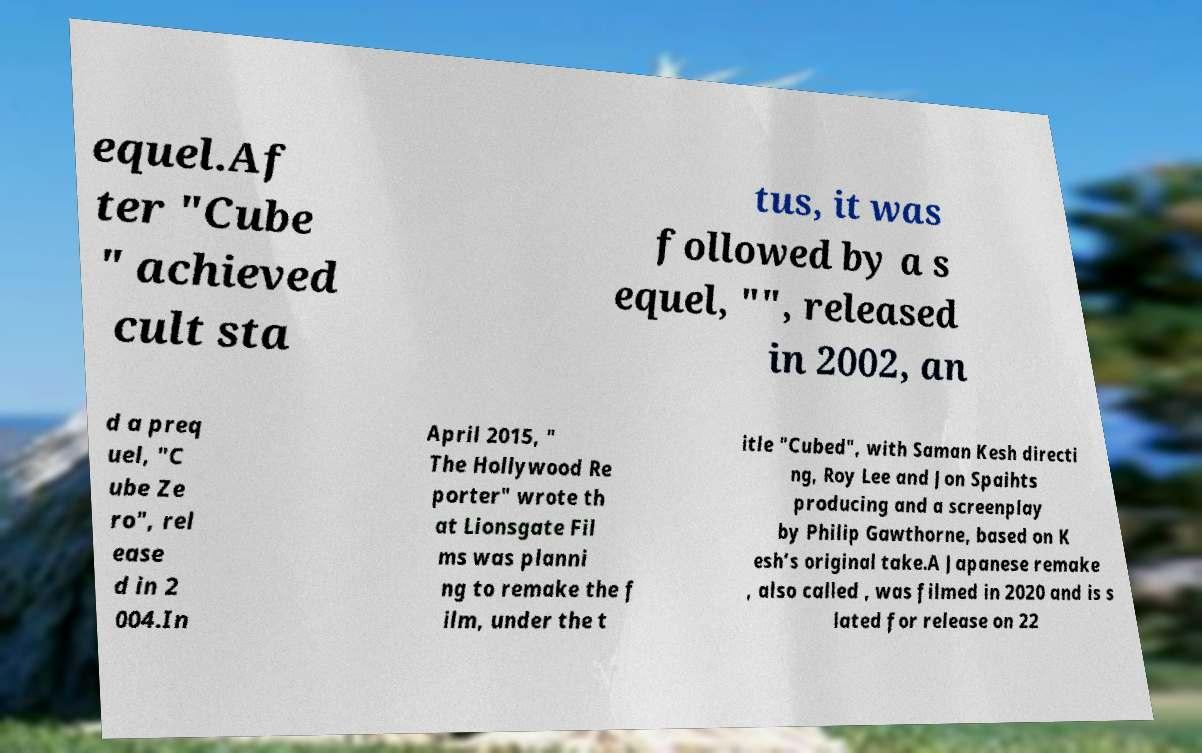Can you accurately transcribe the text from the provided image for me? equel.Af ter "Cube " achieved cult sta tus, it was followed by a s equel, "", released in 2002, an d a preq uel, "C ube Ze ro", rel ease d in 2 004.In April 2015, " The Hollywood Re porter" wrote th at Lionsgate Fil ms was planni ng to remake the f ilm, under the t itle "Cubed", with Saman Kesh directi ng, Roy Lee and Jon Spaihts producing and a screenplay by Philip Gawthorne, based on K esh’s original take.A Japanese remake , also called , was filmed in 2020 and is s lated for release on 22 